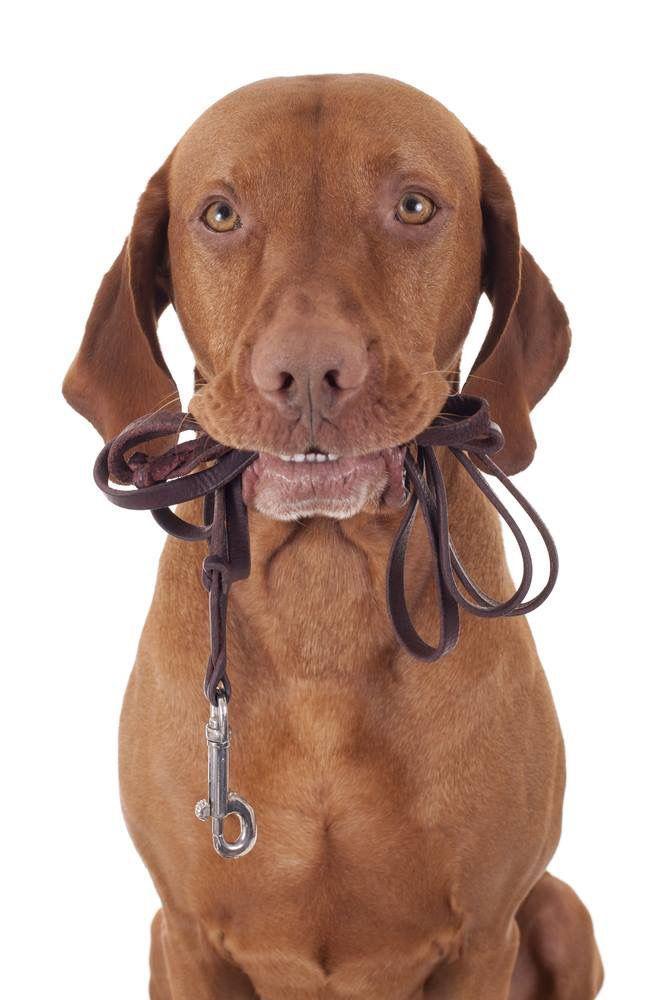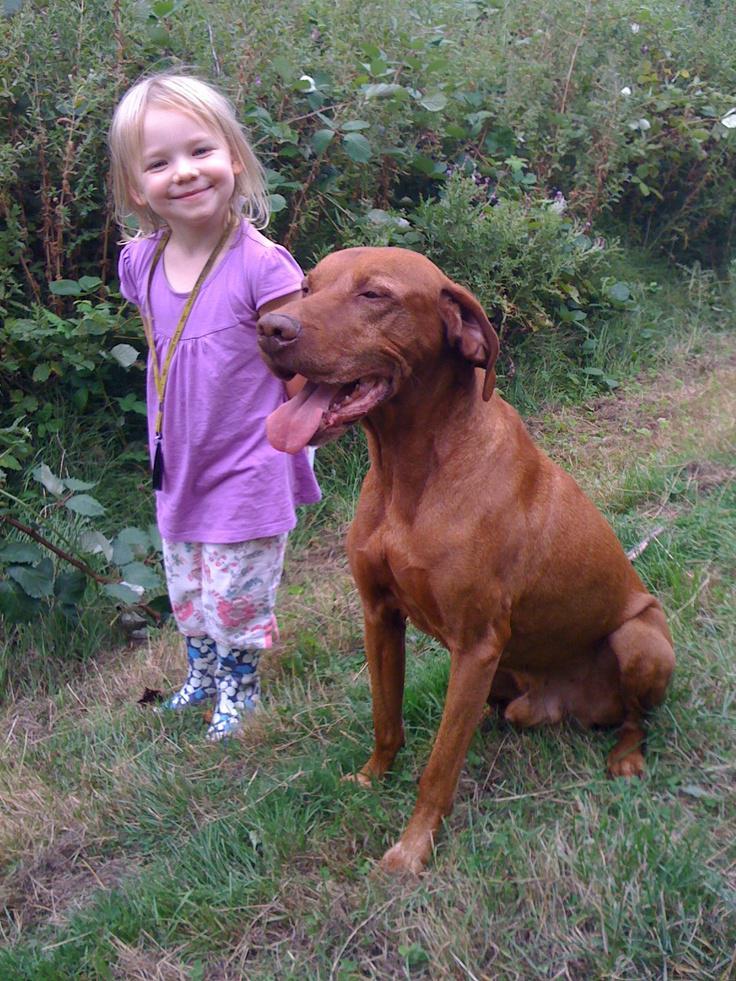The first image is the image on the left, the second image is the image on the right. Considering the images on both sides, is "There's at least one dog on a leash in one picture and the other picture of a dog is taken at the beach." valid? Answer yes or no. No. The first image is the image on the left, the second image is the image on the right. For the images shown, is this caption "A female is standing behind a dog with its head and body turned leftward in the right image." true? Answer yes or no. Yes. 